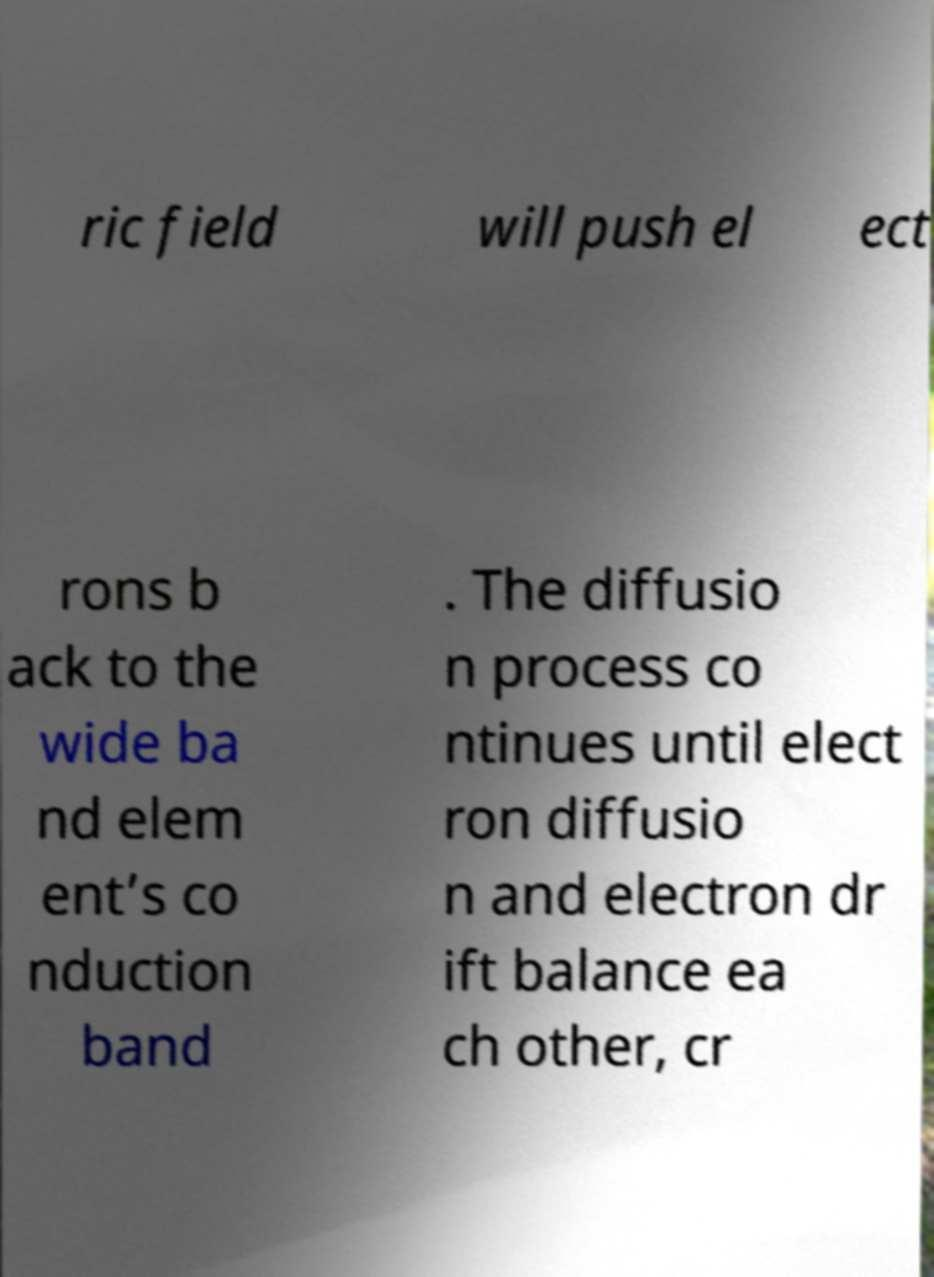Please read and relay the text visible in this image. What does it say? ric field will push el ect rons b ack to the wide ba nd elem ent’s co nduction band . The diffusio n process co ntinues until elect ron diffusio n and electron dr ift balance ea ch other, cr 